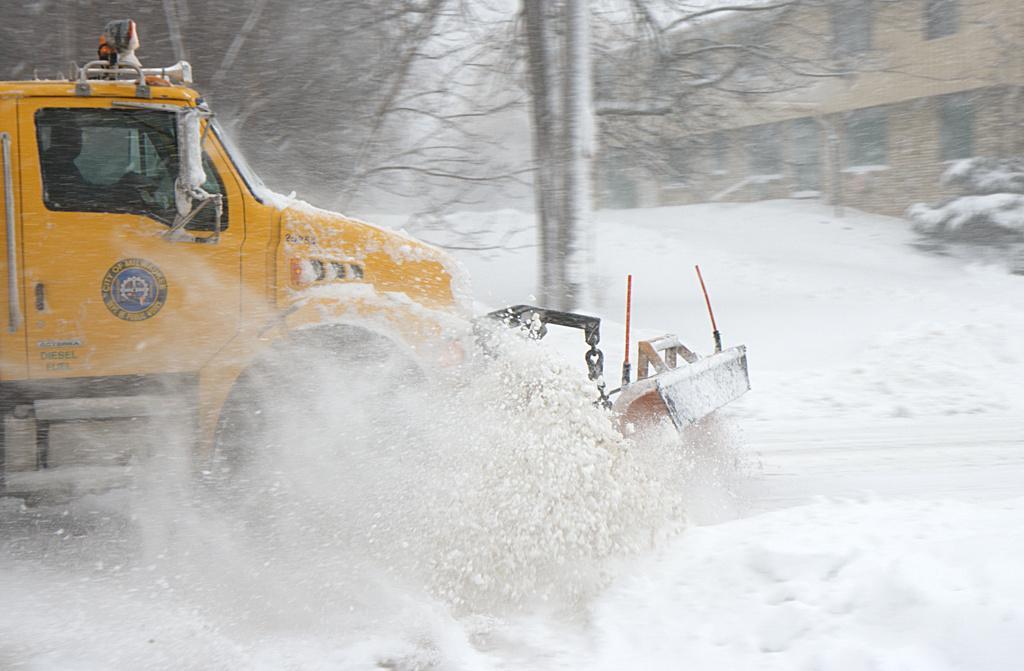Describe this image in one or two sentences. In this image on the left side there is one vehicle in the vehicle there is one person sitting, and at the bottom there is snow. And in the background there are buildings and trees, and the buildings and trees are covered with snow. On the right side there are some plants. 